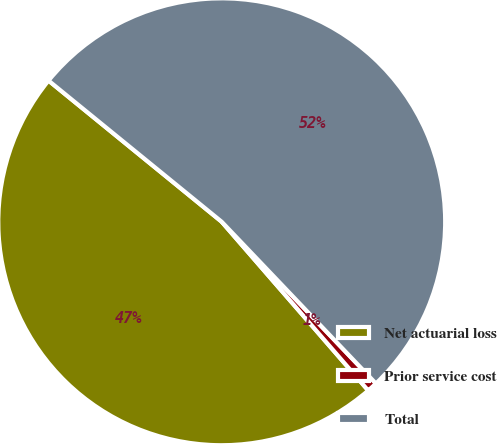<chart> <loc_0><loc_0><loc_500><loc_500><pie_chart><fcel>Net actuarial loss<fcel>Prior service cost<fcel>Total<nl><fcel>47.26%<fcel>0.74%<fcel>51.99%<nl></chart> 